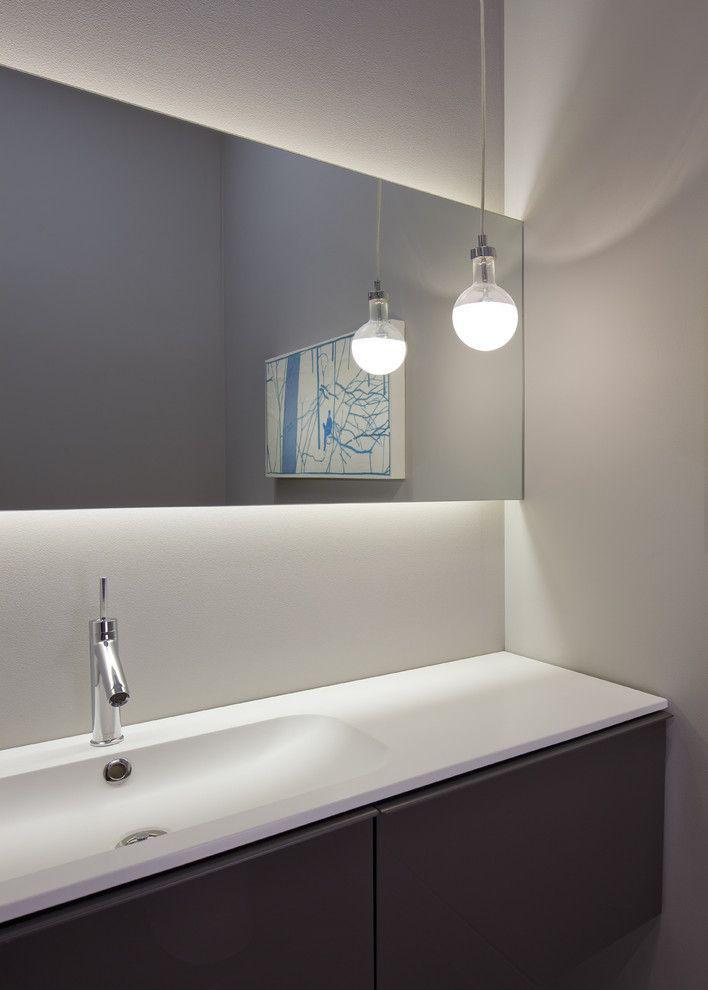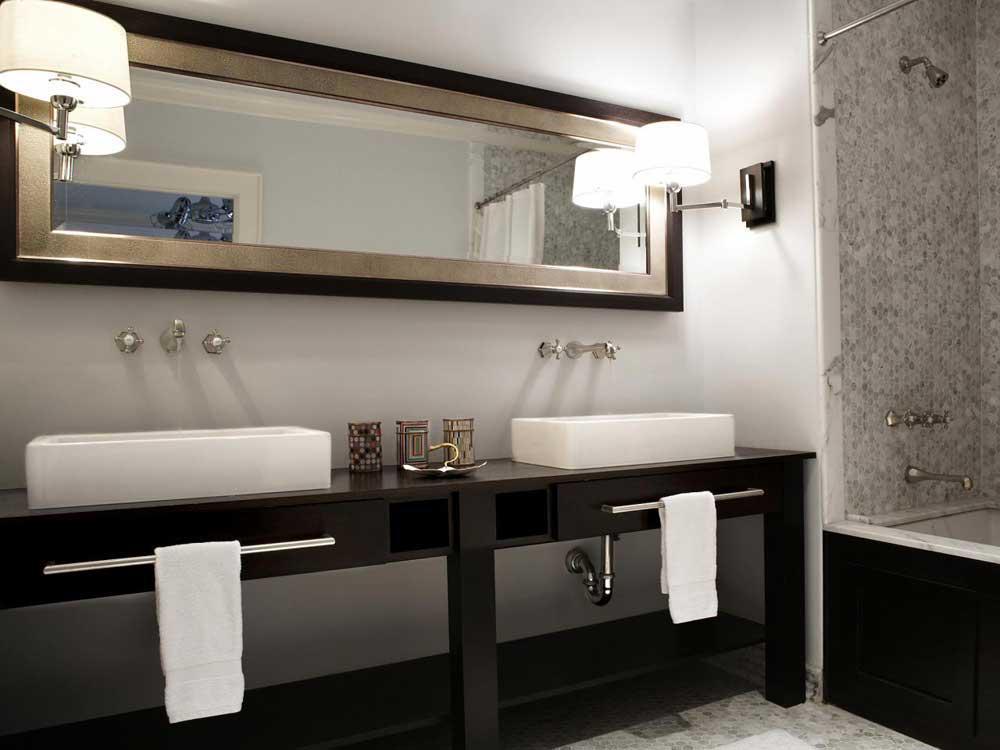The first image is the image on the left, the second image is the image on the right. For the images displayed, is the sentence "An image shows a vanity with side-by-side sinks that rest atop the counter." factually correct? Answer yes or no. Yes. The first image is the image on the left, the second image is the image on the right. Given the left and right images, does the statement "In one image, a wide footed vanity has two matching sinks mounted on top of the vanity and a one large mirror on the wall behind it." hold true? Answer yes or no. Yes. 